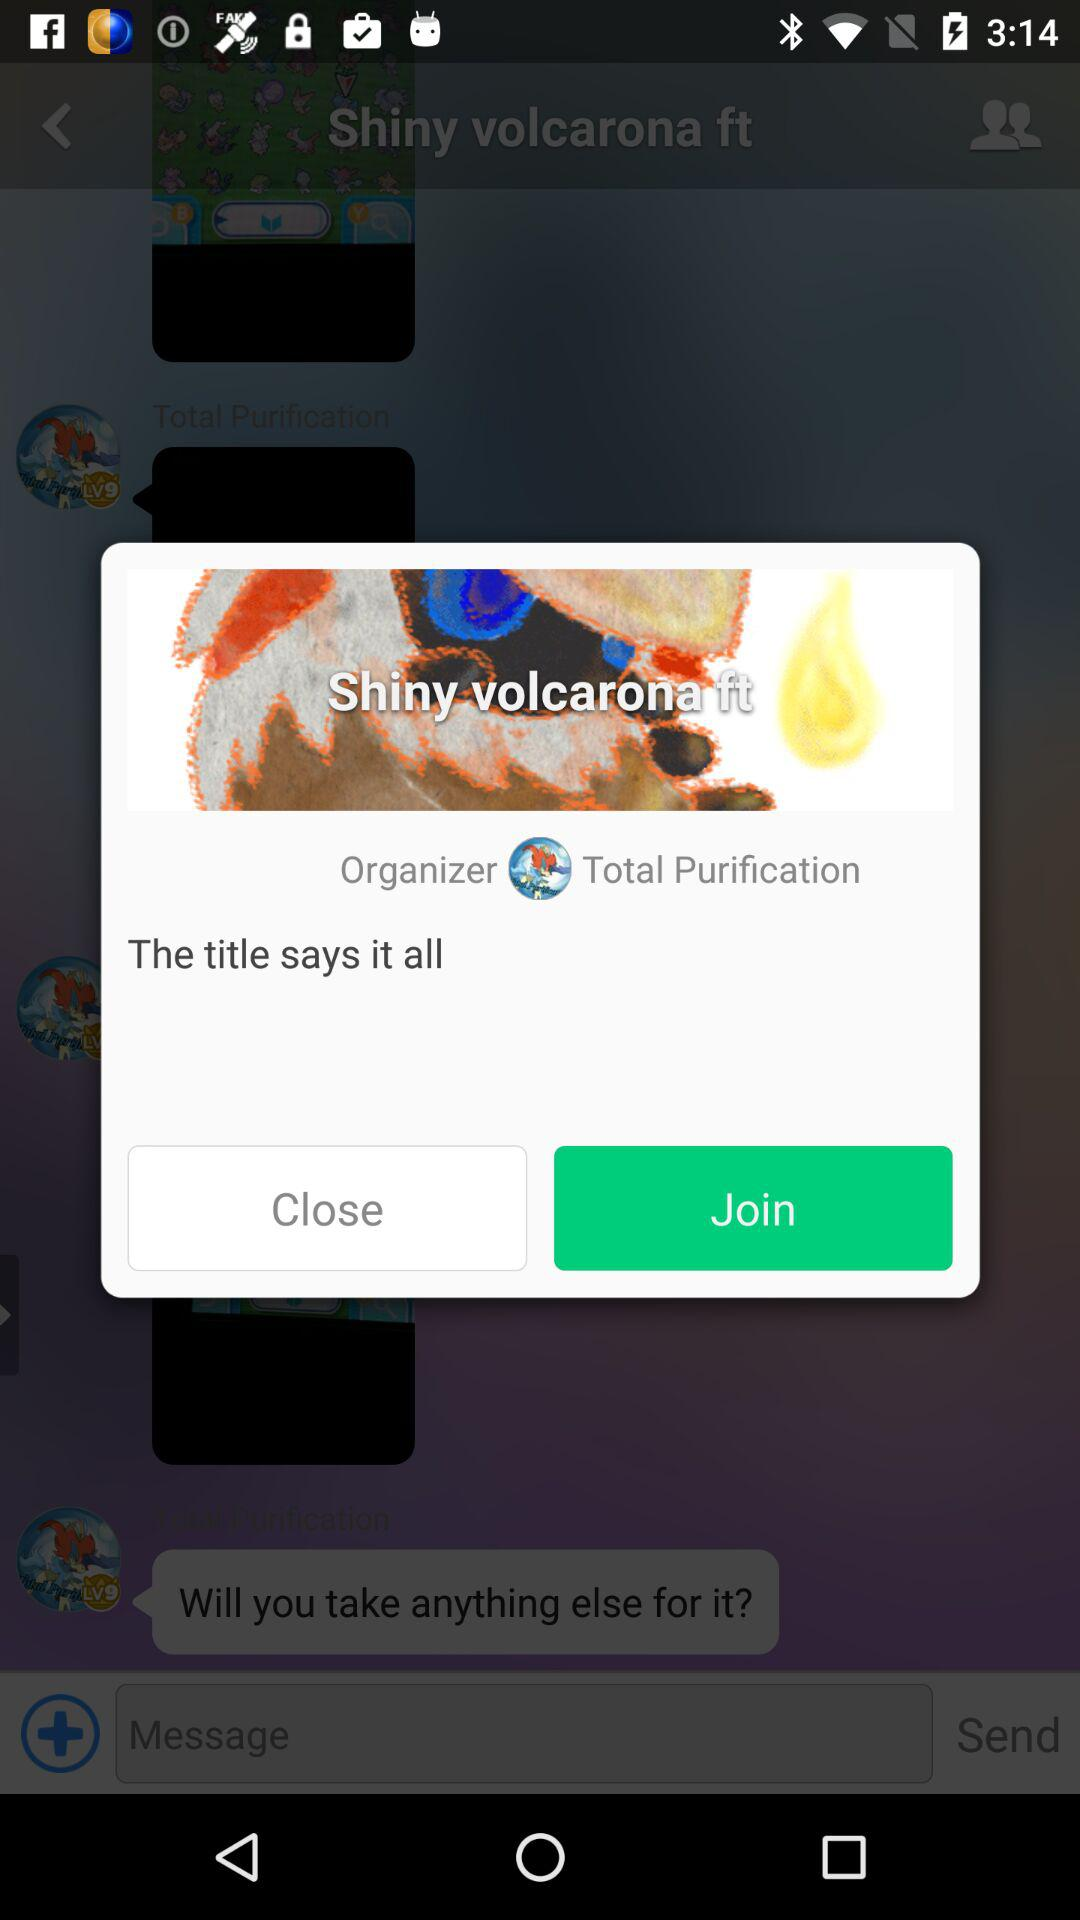What is the name of the application?
When the provided information is insufficient, respond with <no answer>. <no answer> 